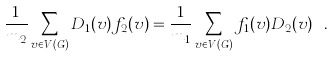Convert formula to latex. <formula><loc_0><loc_0><loc_500><loc_500>\frac { 1 } { m _ { 2 } } \sum _ { v \in V ( G ) } { D _ { 1 } ( v ) f _ { 2 } ( v ) } = \frac { 1 } { m _ { 1 } } \sum _ { v \in V ( G ) } { f _ { 1 } ( v ) D _ { 2 } ( v ) } \ .</formula> 